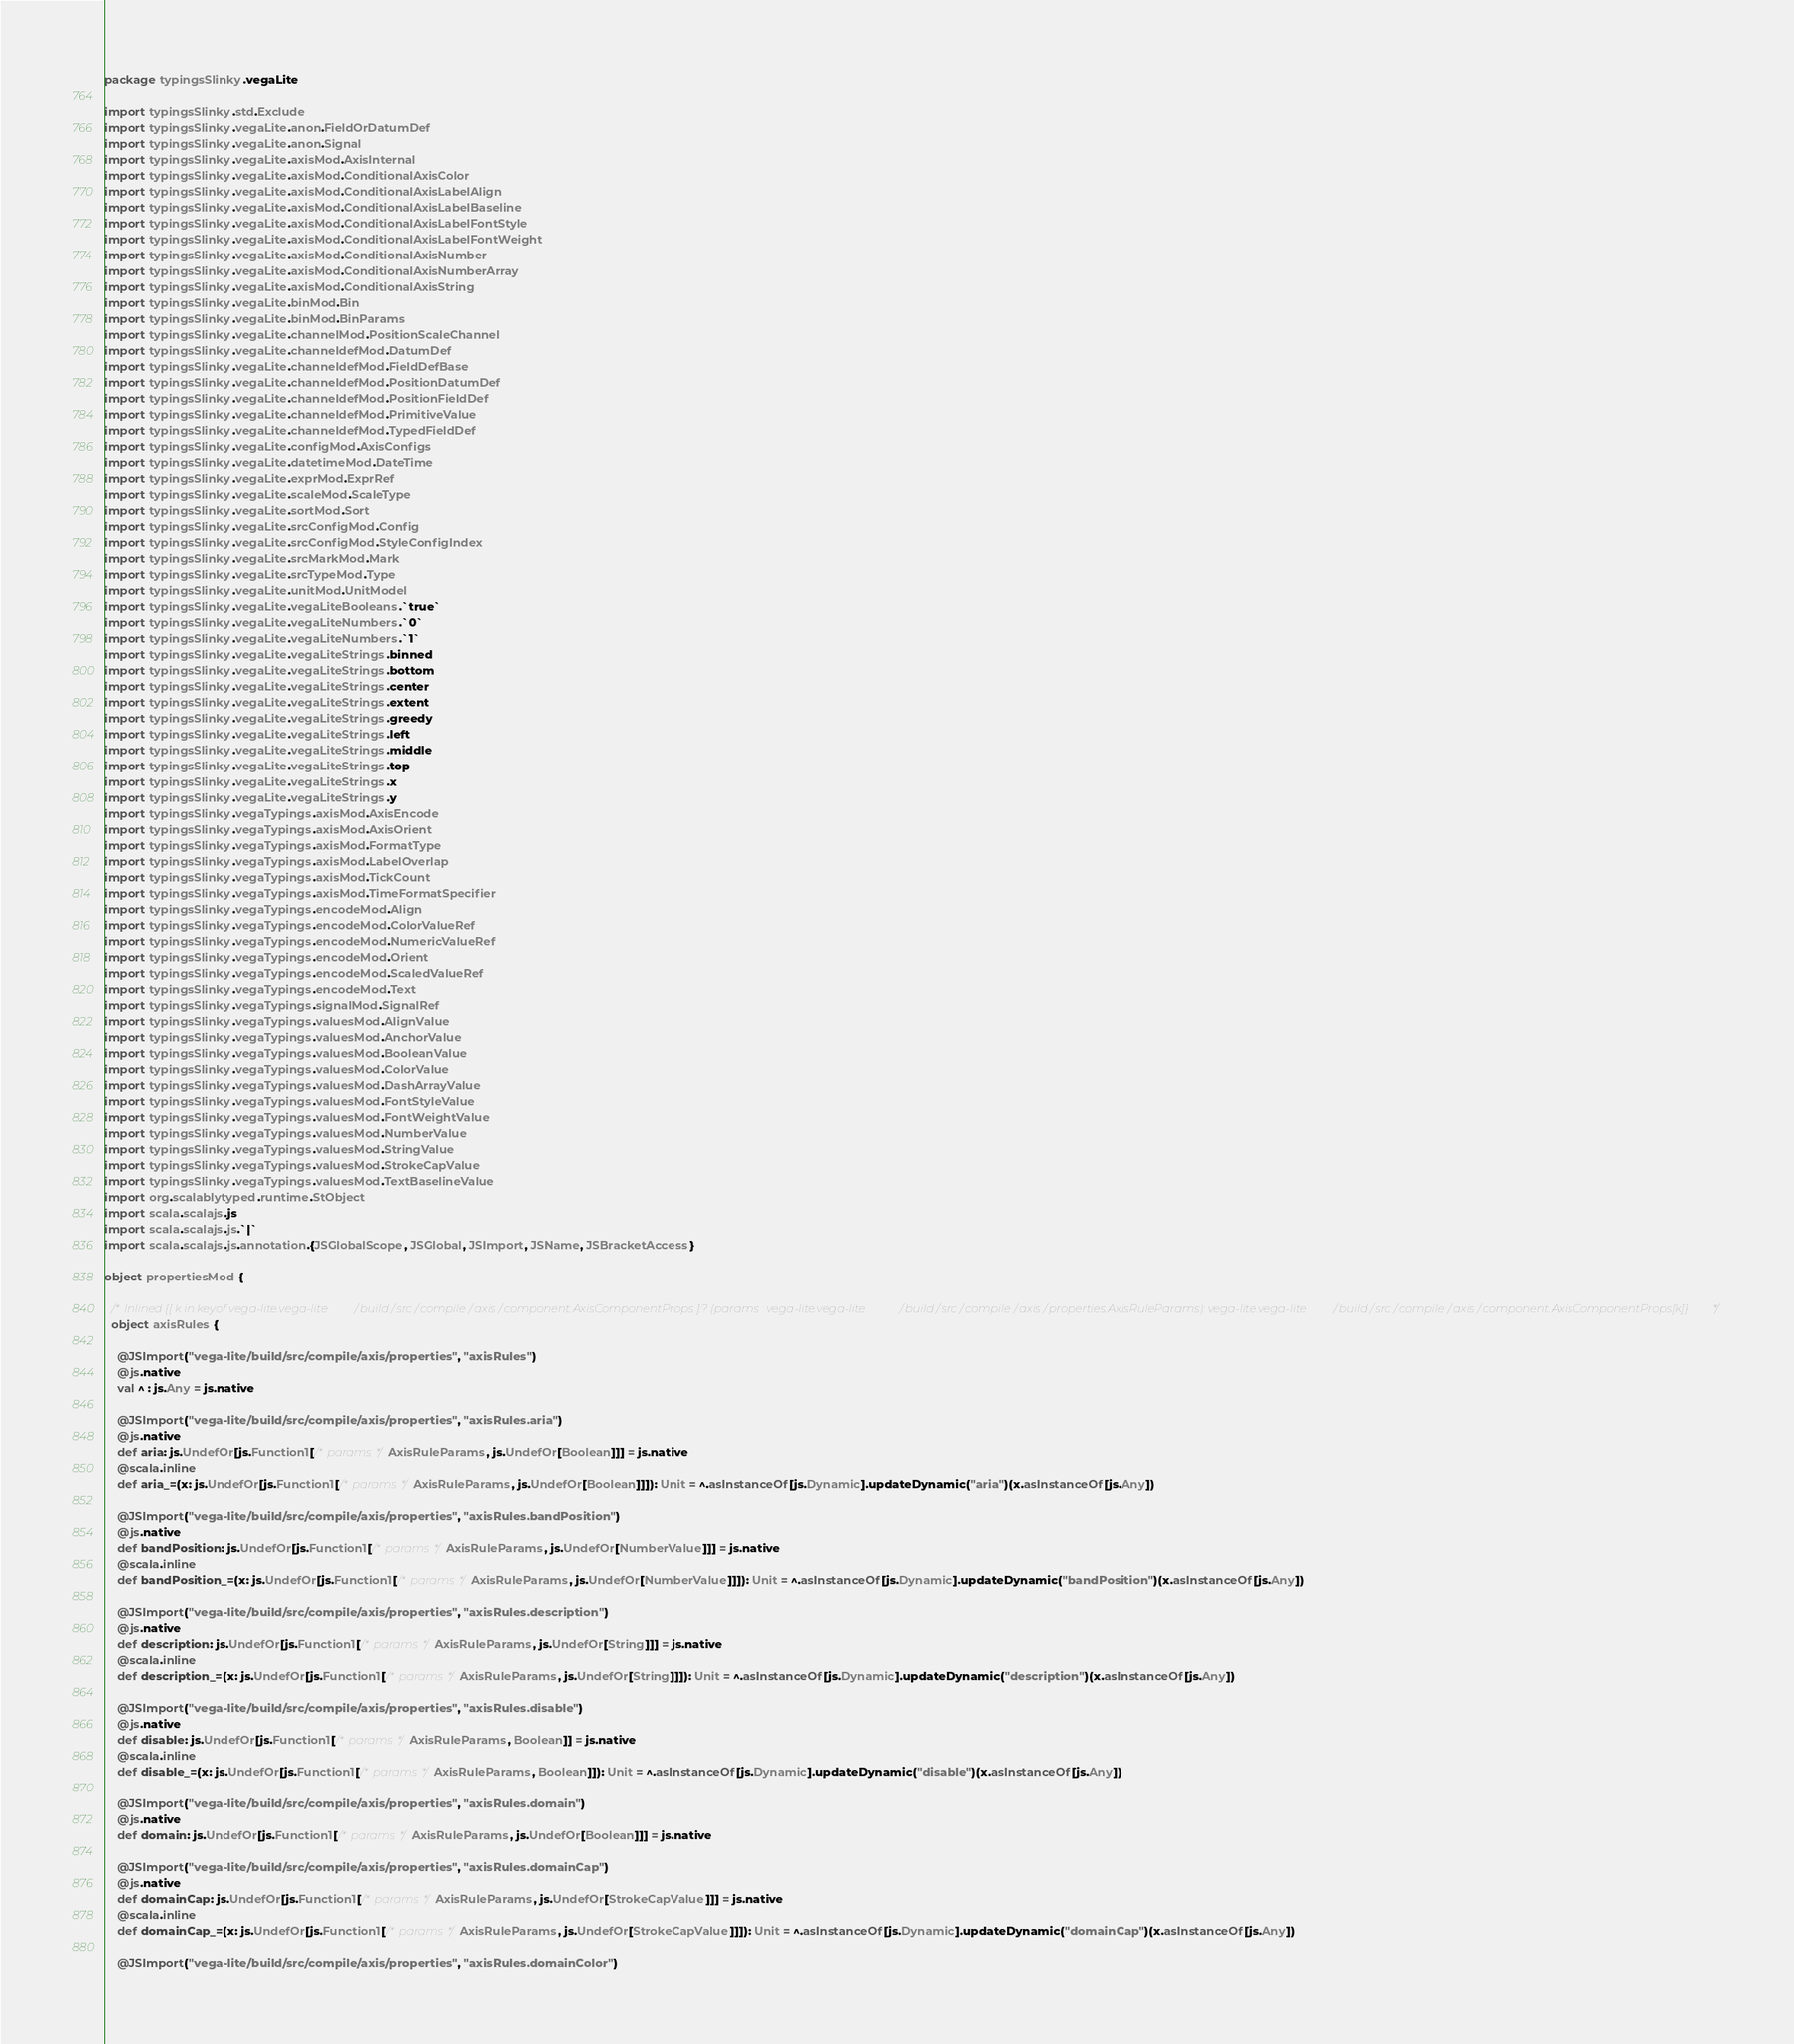Convert code to text. <code><loc_0><loc_0><loc_500><loc_500><_Scala_>package typingsSlinky.vegaLite

import typingsSlinky.std.Exclude
import typingsSlinky.vegaLite.anon.FieldOrDatumDef
import typingsSlinky.vegaLite.anon.Signal
import typingsSlinky.vegaLite.axisMod.AxisInternal
import typingsSlinky.vegaLite.axisMod.ConditionalAxisColor
import typingsSlinky.vegaLite.axisMod.ConditionalAxisLabelAlign
import typingsSlinky.vegaLite.axisMod.ConditionalAxisLabelBaseline
import typingsSlinky.vegaLite.axisMod.ConditionalAxisLabelFontStyle
import typingsSlinky.vegaLite.axisMod.ConditionalAxisLabelFontWeight
import typingsSlinky.vegaLite.axisMod.ConditionalAxisNumber
import typingsSlinky.vegaLite.axisMod.ConditionalAxisNumberArray
import typingsSlinky.vegaLite.axisMod.ConditionalAxisString
import typingsSlinky.vegaLite.binMod.Bin
import typingsSlinky.vegaLite.binMod.BinParams
import typingsSlinky.vegaLite.channelMod.PositionScaleChannel
import typingsSlinky.vegaLite.channeldefMod.DatumDef
import typingsSlinky.vegaLite.channeldefMod.FieldDefBase
import typingsSlinky.vegaLite.channeldefMod.PositionDatumDef
import typingsSlinky.vegaLite.channeldefMod.PositionFieldDef
import typingsSlinky.vegaLite.channeldefMod.PrimitiveValue
import typingsSlinky.vegaLite.channeldefMod.TypedFieldDef
import typingsSlinky.vegaLite.configMod.AxisConfigs
import typingsSlinky.vegaLite.datetimeMod.DateTime
import typingsSlinky.vegaLite.exprMod.ExprRef
import typingsSlinky.vegaLite.scaleMod.ScaleType
import typingsSlinky.vegaLite.sortMod.Sort
import typingsSlinky.vegaLite.srcConfigMod.Config
import typingsSlinky.vegaLite.srcConfigMod.StyleConfigIndex
import typingsSlinky.vegaLite.srcMarkMod.Mark
import typingsSlinky.vegaLite.srcTypeMod.Type
import typingsSlinky.vegaLite.unitMod.UnitModel
import typingsSlinky.vegaLite.vegaLiteBooleans.`true`
import typingsSlinky.vegaLite.vegaLiteNumbers.`0`
import typingsSlinky.vegaLite.vegaLiteNumbers.`1`
import typingsSlinky.vegaLite.vegaLiteStrings.binned
import typingsSlinky.vegaLite.vegaLiteStrings.bottom
import typingsSlinky.vegaLite.vegaLiteStrings.center
import typingsSlinky.vegaLite.vegaLiteStrings.extent
import typingsSlinky.vegaLite.vegaLiteStrings.greedy
import typingsSlinky.vegaLite.vegaLiteStrings.left
import typingsSlinky.vegaLite.vegaLiteStrings.middle
import typingsSlinky.vegaLite.vegaLiteStrings.top
import typingsSlinky.vegaLite.vegaLiteStrings.x
import typingsSlinky.vegaLite.vegaLiteStrings.y
import typingsSlinky.vegaTypings.axisMod.AxisEncode
import typingsSlinky.vegaTypings.axisMod.AxisOrient
import typingsSlinky.vegaTypings.axisMod.FormatType
import typingsSlinky.vegaTypings.axisMod.LabelOverlap
import typingsSlinky.vegaTypings.axisMod.TickCount
import typingsSlinky.vegaTypings.axisMod.TimeFormatSpecifier
import typingsSlinky.vegaTypings.encodeMod.Align
import typingsSlinky.vegaTypings.encodeMod.ColorValueRef
import typingsSlinky.vegaTypings.encodeMod.NumericValueRef
import typingsSlinky.vegaTypings.encodeMod.Orient
import typingsSlinky.vegaTypings.encodeMod.ScaledValueRef
import typingsSlinky.vegaTypings.encodeMod.Text
import typingsSlinky.vegaTypings.signalMod.SignalRef
import typingsSlinky.vegaTypings.valuesMod.AlignValue
import typingsSlinky.vegaTypings.valuesMod.AnchorValue
import typingsSlinky.vegaTypings.valuesMod.BooleanValue
import typingsSlinky.vegaTypings.valuesMod.ColorValue
import typingsSlinky.vegaTypings.valuesMod.DashArrayValue
import typingsSlinky.vegaTypings.valuesMod.FontStyleValue
import typingsSlinky.vegaTypings.valuesMod.FontWeightValue
import typingsSlinky.vegaTypings.valuesMod.NumberValue
import typingsSlinky.vegaTypings.valuesMod.StringValue
import typingsSlinky.vegaTypings.valuesMod.StrokeCapValue
import typingsSlinky.vegaTypings.valuesMod.TextBaselineValue
import org.scalablytyped.runtime.StObject
import scala.scalajs.js
import scala.scalajs.js.`|`
import scala.scalajs.js.annotation.{JSGlobalScope, JSGlobal, JSImport, JSName, JSBracketAccess}

object propertiesMod {
  
  /* Inlined {[ k in keyof vega-lite.vega-lite/build/src/compile/axis/component.AxisComponentProps ]:? (params : vega-lite.vega-lite/build/src/compile/axis/properties.AxisRuleParams): vega-lite.vega-lite/build/src/compile/axis/component.AxisComponentProps[k]} */
  object axisRules {
    
    @JSImport("vega-lite/build/src/compile/axis/properties", "axisRules")
    @js.native
    val ^ : js.Any = js.native
    
    @JSImport("vega-lite/build/src/compile/axis/properties", "axisRules.aria")
    @js.native
    def aria: js.UndefOr[js.Function1[/* params */ AxisRuleParams, js.UndefOr[Boolean]]] = js.native
    @scala.inline
    def aria_=(x: js.UndefOr[js.Function1[/* params */ AxisRuleParams, js.UndefOr[Boolean]]]): Unit = ^.asInstanceOf[js.Dynamic].updateDynamic("aria")(x.asInstanceOf[js.Any])
    
    @JSImport("vega-lite/build/src/compile/axis/properties", "axisRules.bandPosition")
    @js.native
    def bandPosition: js.UndefOr[js.Function1[/* params */ AxisRuleParams, js.UndefOr[NumberValue]]] = js.native
    @scala.inline
    def bandPosition_=(x: js.UndefOr[js.Function1[/* params */ AxisRuleParams, js.UndefOr[NumberValue]]]): Unit = ^.asInstanceOf[js.Dynamic].updateDynamic("bandPosition")(x.asInstanceOf[js.Any])
    
    @JSImport("vega-lite/build/src/compile/axis/properties", "axisRules.description")
    @js.native
    def description: js.UndefOr[js.Function1[/* params */ AxisRuleParams, js.UndefOr[String]]] = js.native
    @scala.inline
    def description_=(x: js.UndefOr[js.Function1[/* params */ AxisRuleParams, js.UndefOr[String]]]): Unit = ^.asInstanceOf[js.Dynamic].updateDynamic("description")(x.asInstanceOf[js.Any])
    
    @JSImport("vega-lite/build/src/compile/axis/properties", "axisRules.disable")
    @js.native
    def disable: js.UndefOr[js.Function1[/* params */ AxisRuleParams, Boolean]] = js.native
    @scala.inline
    def disable_=(x: js.UndefOr[js.Function1[/* params */ AxisRuleParams, Boolean]]): Unit = ^.asInstanceOf[js.Dynamic].updateDynamic("disable")(x.asInstanceOf[js.Any])
    
    @JSImport("vega-lite/build/src/compile/axis/properties", "axisRules.domain")
    @js.native
    def domain: js.UndefOr[js.Function1[/* params */ AxisRuleParams, js.UndefOr[Boolean]]] = js.native
    
    @JSImport("vega-lite/build/src/compile/axis/properties", "axisRules.domainCap")
    @js.native
    def domainCap: js.UndefOr[js.Function1[/* params */ AxisRuleParams, js.UndefOr[StrokeCapValue]]] = js.native
    @scala.inline
    def domainCap_=(x: js.UndefOr[js.Function1[/* params */ AxisRuleParams, js.UndefOr[StrokeCapValue]]]): Unit = ^.asInstanceOf[js.Dynamic].updateDynamic("domainCap")(x.asInstanceOf[js.Any])
    
    @JSImport("vega-lite/build/src/compile/axis/properties", "axisRules.domainColor")</code> 